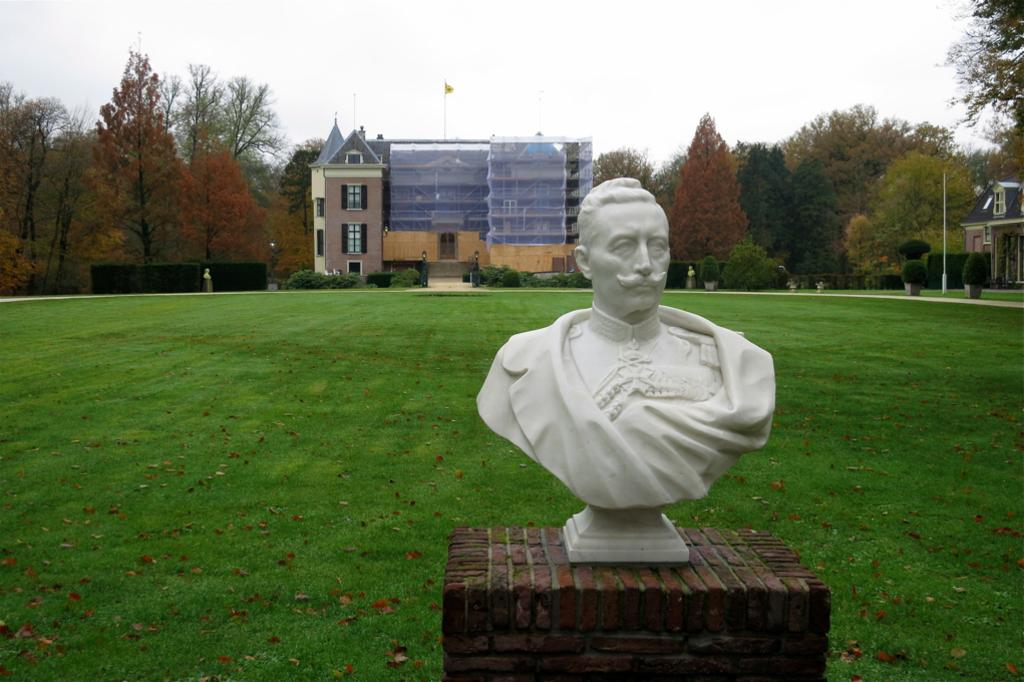What is the main subject of the image? There is a sculpture in the image. Where is the sculpture located? The sculpture is placed on a path. What type of vegetation can be seen in the image? There is grass visible in the image. What else can be seen in the image besides the sculpture and grass? There are buildings and trees in the image. What type of health advice is being given in the image? There is no health advice present in the image; it features a sculpture on a path with grass, buildings, and trees. How many bricks are used to construct the buildings in the image? The text does not provide information about the construction materials of the buildings, so it is impossible to determine the number of bricks used. 